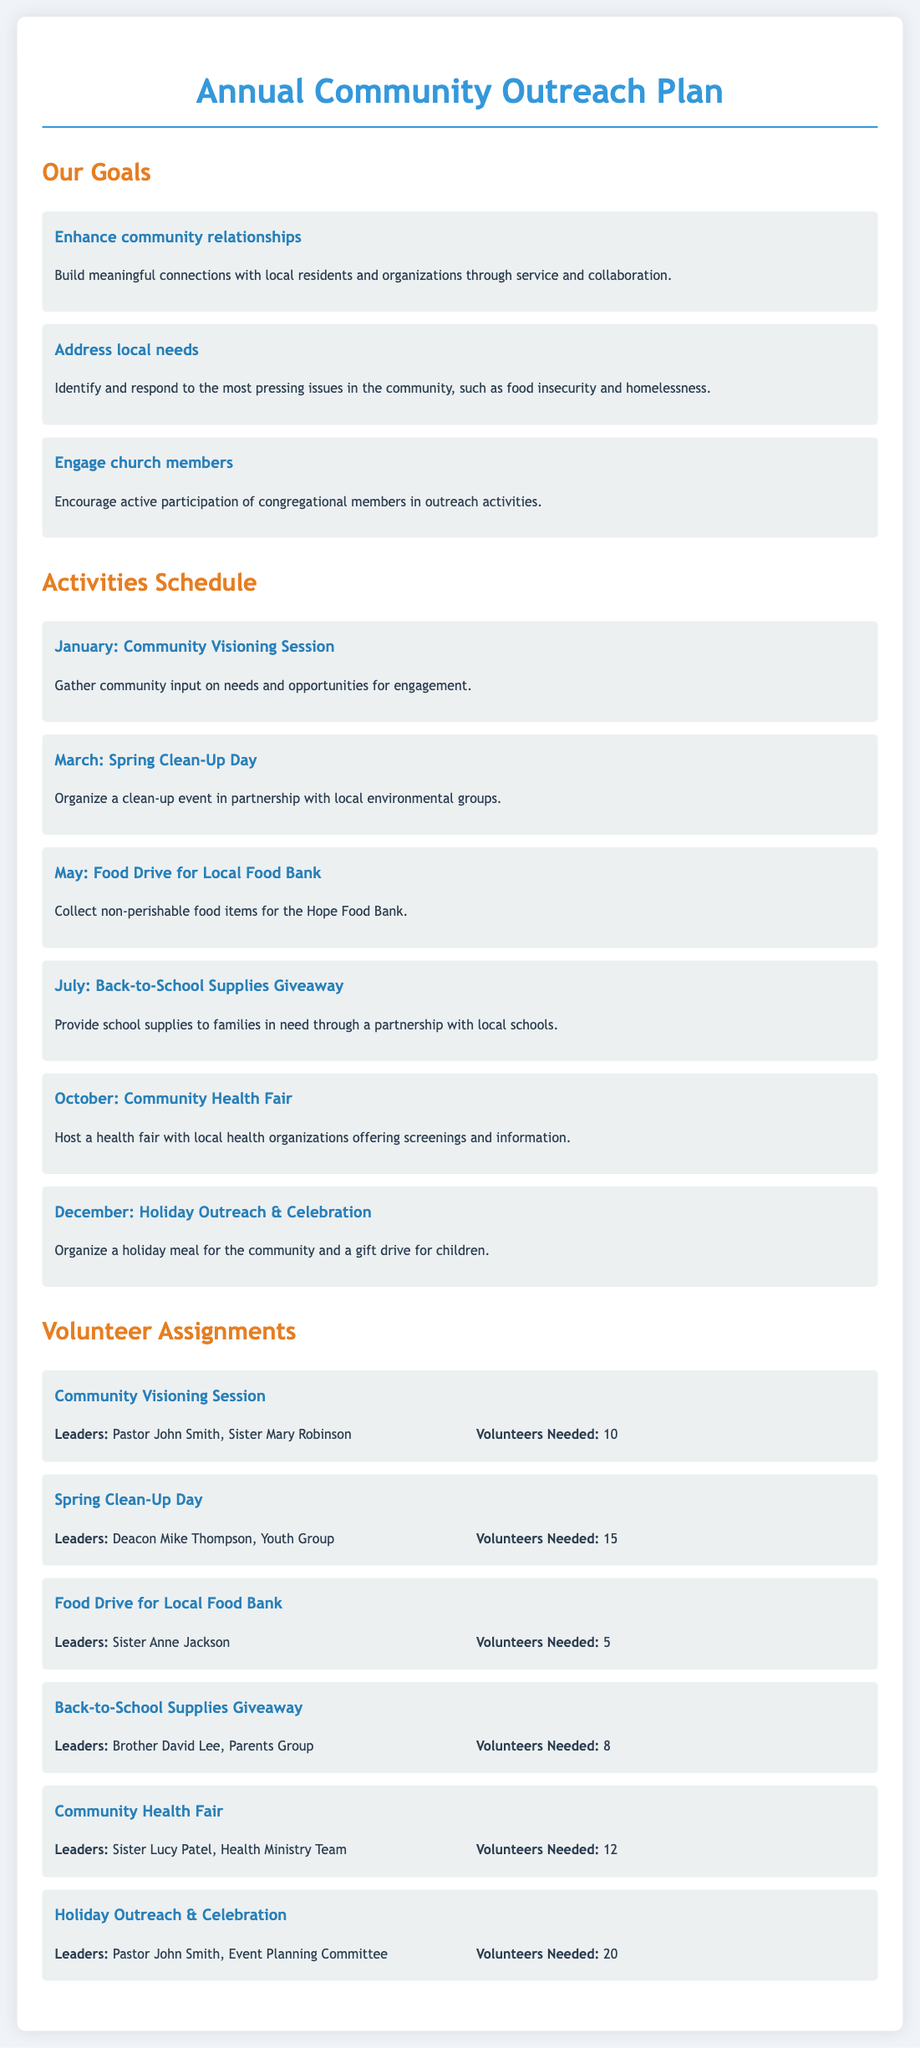What is the first goal listed? The first goal mentioned in the document is to "Enhance community relationships."
Answer: Enhance community relationships How many activities are scheduled for the year? The document lists a total of six activities planned for the year.
Answer: 6 Who leads the Food Drive for Local Food Bank? The document states that Sister Anne Jackson leads the Food Drive for Local Food Bank.
Answer: Sister Anne Jackson What is the focus of the October activity? The October activity focuses on hosting a Community Health Fair.
Answer: Community Health Fair How many volunteers are needed for the Holiday Outreach & Celebration? The document indicates that 20 volunteers are needed for the Holiday Outreach & Celebration.
Answer: 20 Which activity is associated with the month of May? The activity scheduled for May is the Food Drive for Local Food Bank.
Answer: Food Drive for Local Food Bank What is the purpose of the January activity? The purpose of the January activity is to gather community input on needs and opportunities for engagement.
Answer: Gather community input What is the total number of volunteers needed across all activities? To find the total, add the volunteers needed for each activity: 10 + 15 + 5 + 8 + 12 + 20 = 70.
Answer: 70 